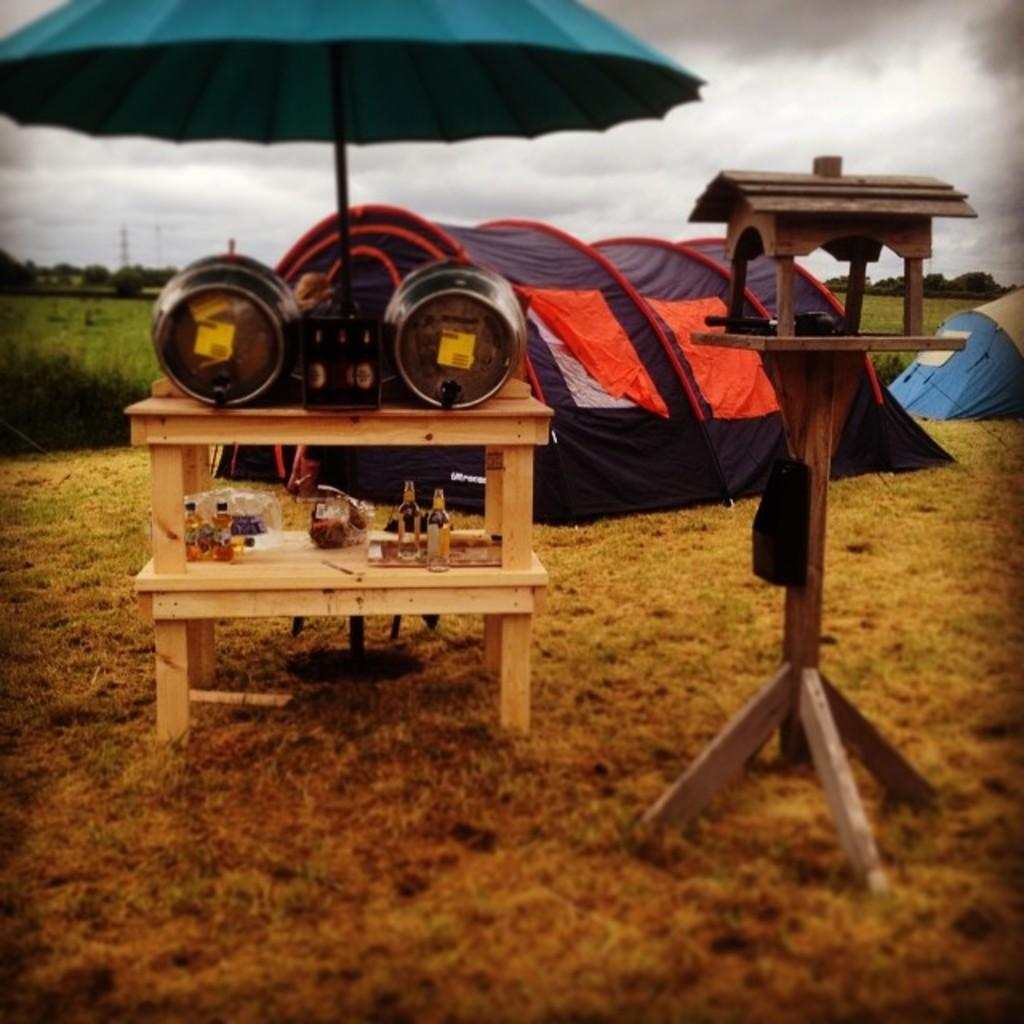What type of storage or display system is being used in the image? There are objects on wooden racks in the image. What type of weather protection is visible in the image? An umbrella is visible in the image. What type of temporary shelter is present in the image? Tents are present in the image. What material is used for the wooden object in the image? There is a wooden object in the image. What type of natural environment is visible in the background of the image? Trees are visible in the background of the image. What is the color of the sky in the image? The sky appears to be white in color. How many yaks are grazing near the wooden racks in the image? There are no yaks present in the image. What type of grain is stored in the wooden racks in the image? There is no grain visible in the image; only objects are present on the wooden racks. Where is the dock located in the image? There is no dock present in the image. 